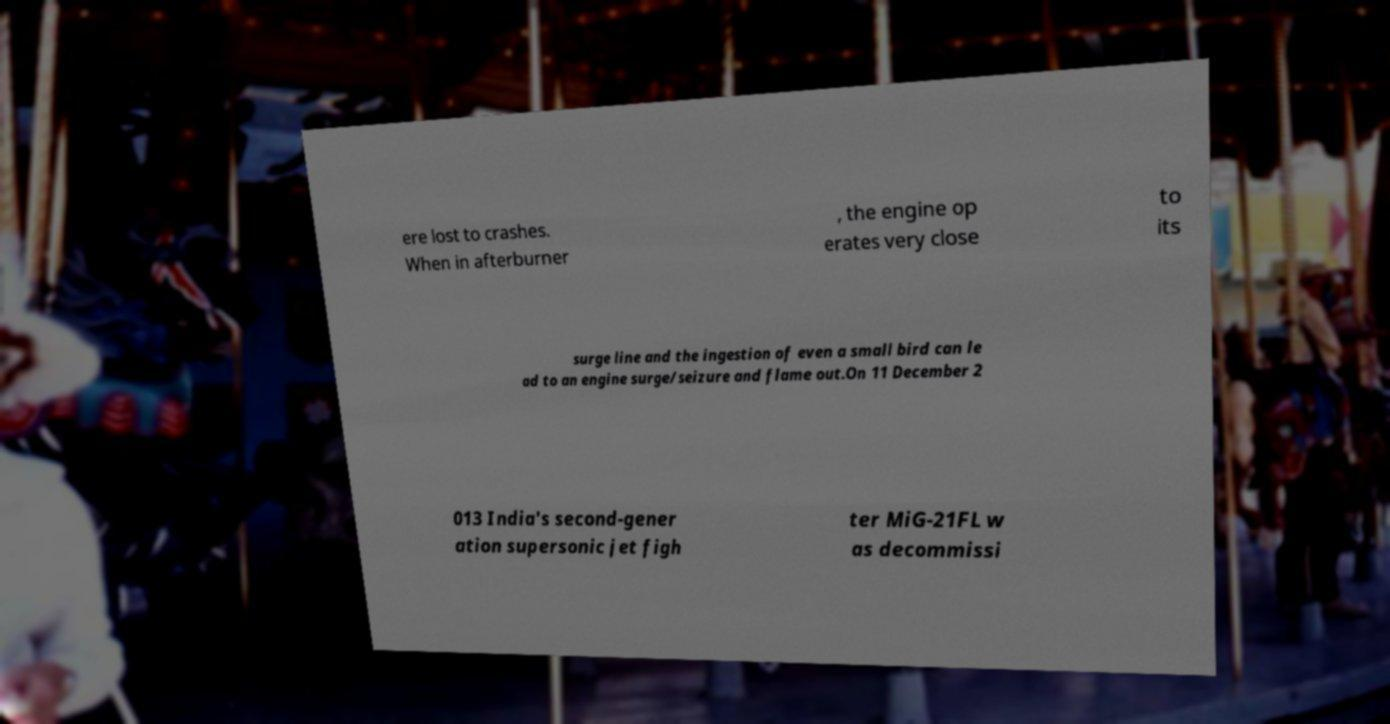What messages or text are displayed in this image? I need them in a readable, typed format. ere lost to crashes. When in afterburner , the engine op erates very close to its surge line and the ingestion of even a small bird can le ad to an engine surge/seizure and flame out.On 11 December 2 013 India's second-gener ation supersonic jet figh ter MiG-21FL w as decommissi 